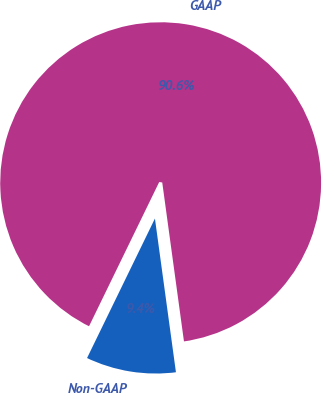<chart> <loc_0><loc_0><loc_500><loc_500><pie_chart><fcel>Non-GAAP<fcel>GAAP<nl><fcel>9.37%<fcel>90.63%<nl></chart> 